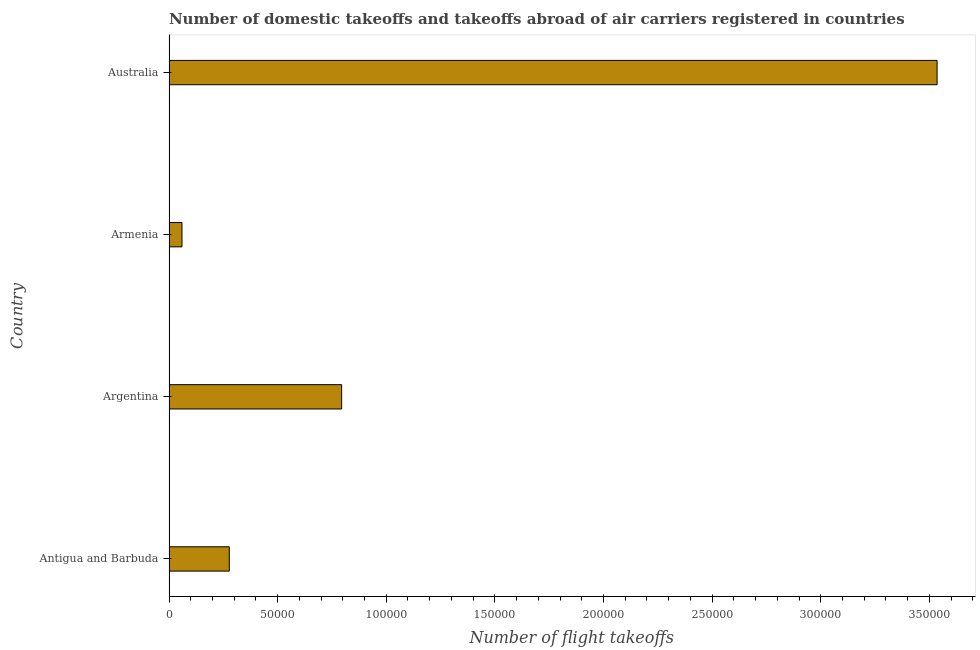Does the graph contain any zero values?
Provide a short and direct response. No. Does the graph contain grids?
Provide a succinct answer. No. What is the title of the graph?
Make the answer very short. Number of domestic takeoffs and takeoffs abroad of air carriers registered in countries. What is the label or title of the X-axis?
Provide a short and direct response. Number of flight takeoffs. What is the number of flight takeoffs in Australia?
Your answer should be very brief. 3.54e+05. Across all countries, what is the maximum number of flight takeoffs?
Your answer should be compact. 3.54e+05. Across all countries, what is the minimum number of flight takeoffs?
Give a very brief answer. 5975. In which country was the number of flight takeoffs minimum?
Your response must be concise. Armenia. What is the sum of the number of flight takeoffs?
Your response must be concise. 4.67e+05. What is the difference between the number of flight takeoffs in Antigua and Barbuda and Argentina?
Offer a terse response. -5.17e+04. What is the average number of flight takeoffs per country?
Provide a short and direct response. 1.17e+05. What is the median number of flight takeoffs?
Your response must be concise. 5.36e+04. What is the ratio of the number of flight takeoffs in Antigua and Barbuda to that in Armenia?
Offer a terse response. 4.64. Is the number of flight takeoffs in Antigua and Barbuda less than that in Armenia?
Ensure brevity in your answer.  No. Is the difference between the number of flight takeoffs in Argentina and Australia greater than the difference between any two countries?
Make the answer very short. No. What is the difference between the highest and the second highest number of flight takeoffs?
Your response must be concise. 2.74e+05. What is the difference between the highest and the lowest number of flight takeoffs?
Make the answer very short. 3.48e+05. In how many countries, is the number of flight takeoffs greater than the average number of flight takeoffs taken over all countries?
Provide a short and direct response. 1. How many bars are there?
Provide a succinct answer. 4. How many countries are there in the graph?
Ensure brevity in your answer.  4. What is the difference between two consecutive major ticks on the X-axis?
Your response must be concise. 5.00e+04. Are the values on the major ticks of X-axis written in scientific E-notation?
Your answer should be very brief. No. What is the Number of flight takeoffs of Antigua and Barbuda?
Keep it short and to the point. 2.77e+04. What is the Number of flight takeoffs of Argentina?
Offer a terse response. 7.95e+04. What is the Number of flight takeoffs in Armenia?
Offer a terse response. 5975. What is the Number of flight takeoffs of Australia?
Your response must be concise. 3.54e+05. What is the difference between the Number of flight takeoffs in Antigua and Barbuda and Argentina?
Provide a succinct answer. -5.17e+04. What is the difference between the Number of flight takeoffs in Antigua and Barbuda and Armenia?
Make the answer very short. 2.18e+04. What is the difference between the Number of flight takeoffs in Antigua and Barbuda and Australia?
Provide a succinct answer. -3.26e+05. What is the difference between the Number of flight takeoffs in Argentina and Armenia?
Provide a succinct answer. 7.35e+04. What is the difference between the Number of flight takeoffs in Argentina and Australia?
Ensure brevity in your answer.  -2.74e+05. What is the difference between the Number of flight takeoffs in Armenia and Australia?
Ensure brevity in your answer.  -3.48e+05. What is the ratio of the Number of flight takeoffs in Antigua and Barbuda to that in Argentina?
Make the answer very short. 0.35. What is the ratio of the Number of flight takeoffs in Antigua and Barbuda to that in Armenia?
Make the answer very short. 4.64. What is the ratio of the Number of flight takeoffs in Antigua and Barbuda to that in Australia?
Your response must be concise. 0.08. What is the ratio of the Number of flight takeoffs in Argentina to that in Australia?
Provide a short and direct response. 0.23. What is the ratio of the Number of flight takeoffs in Armenia to that in Australia?
Offer a very short reply. 0.02. 